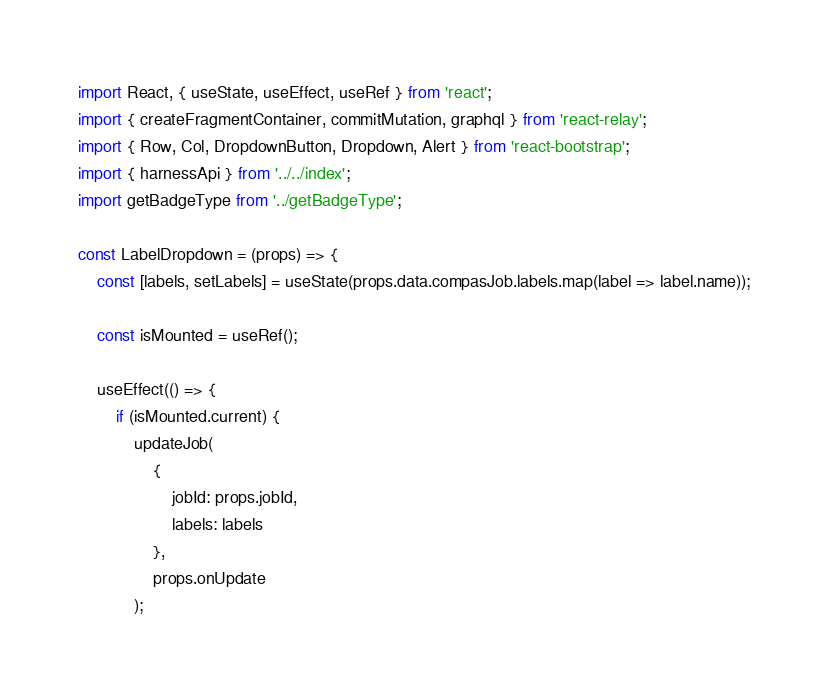Convert code to text. <code><loc_0><loc_0><loc_500><loc_500><_JavaScript_>import React, { useState, useEffect, useRef } from 'react';
import { createFragmentContainer, commitMutation, graphql } from 'react-relay';
import { Row, Col, DropdownButton, Dropdown, Alert } from 'react-bootstrap';
import { harnessApi } from '../../index';
import getBadgeType from '../getBadgeType';

const LabelDropdown = (props) => {
    const [labels, setLabels] = useState(props.data.compasJob.labels.map(label => label.name));
    
    const isMounted = useRef();

    useEffect(() => {
        if (isMounted.current) {
            updateJob(
                {
                    jobId: props.jobId,
                    labels: labels
                },
                props.onUpdate
            );</code> 